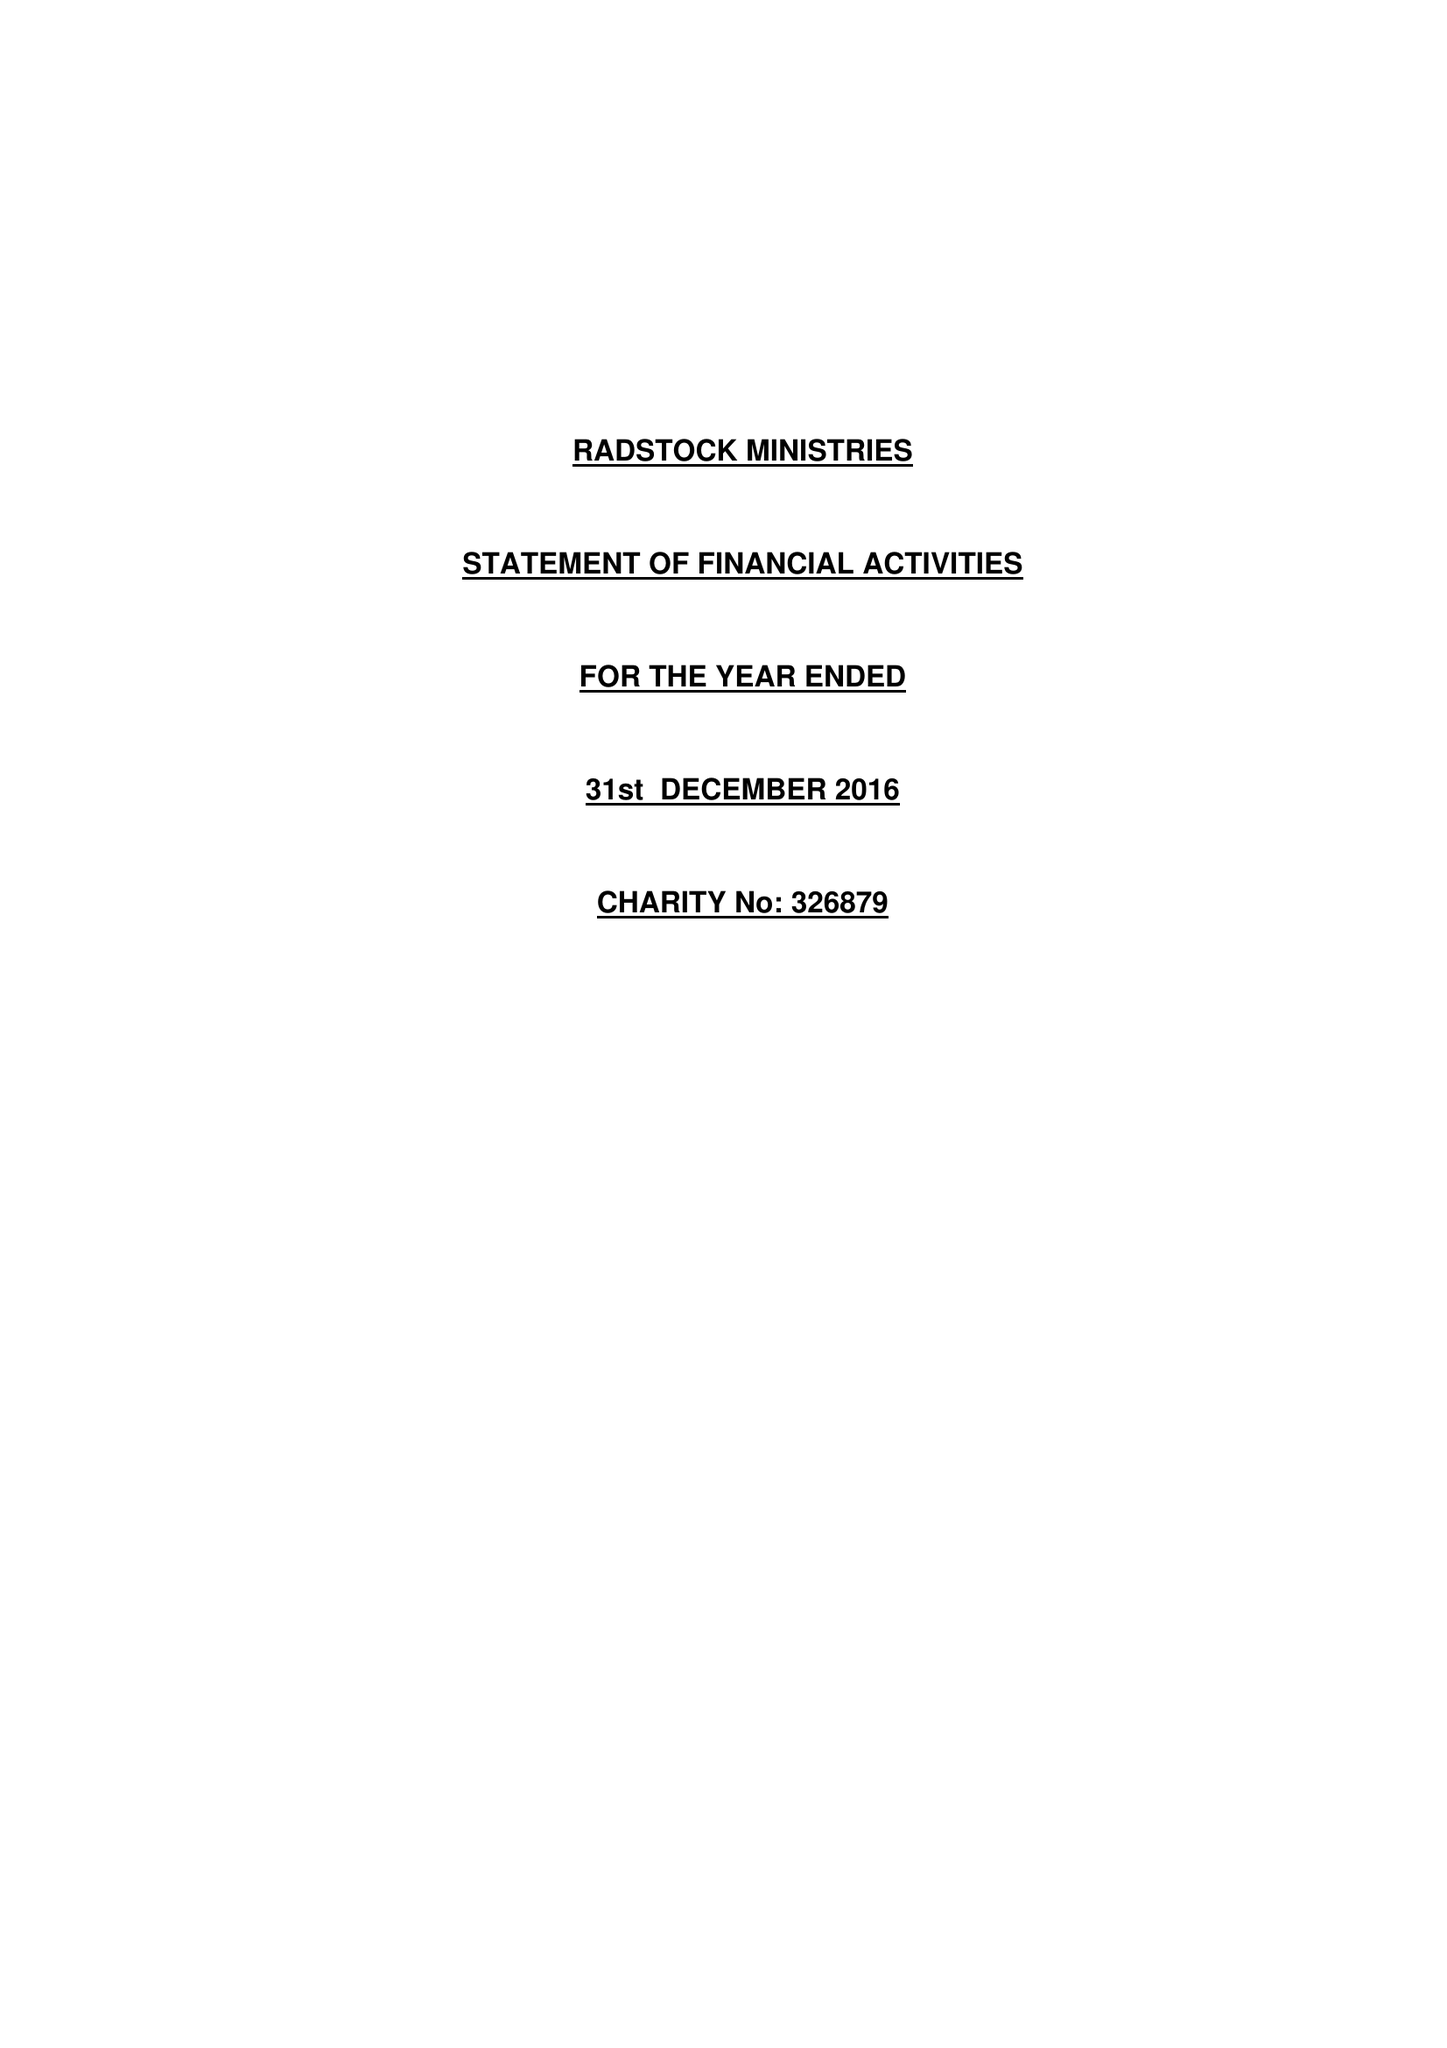What is the value for the report_date?
Answer the question using a single word or phrase. 2016-12-31 